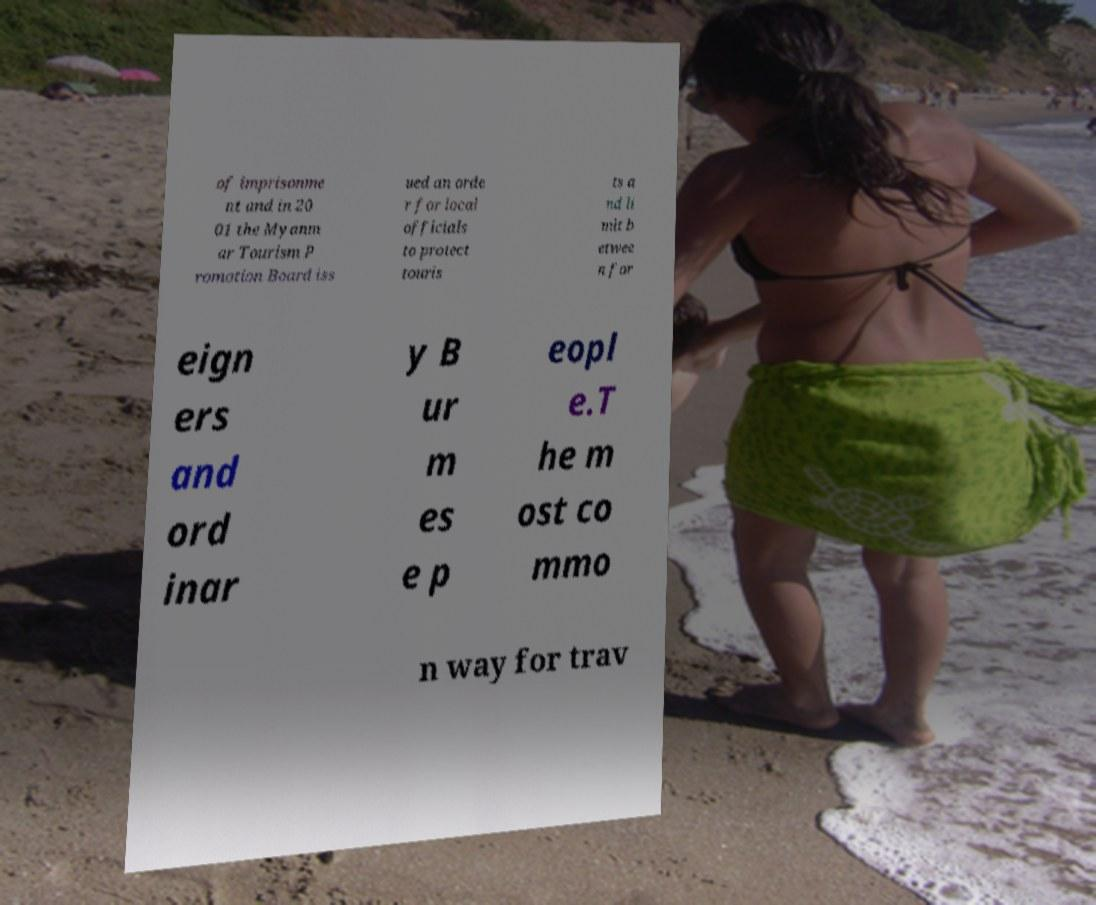Can you accurately transcribe the text from the provided image for me? of imprisonme nt and in 20 01 the Myanm ar Tourism P romotion Board iss ued an orde r for local officials to protect touris ts a nd li mit b etwee n for eign ers and ord inar y B ur m es e p eopl e.T he m ost co mmo n way for trav 